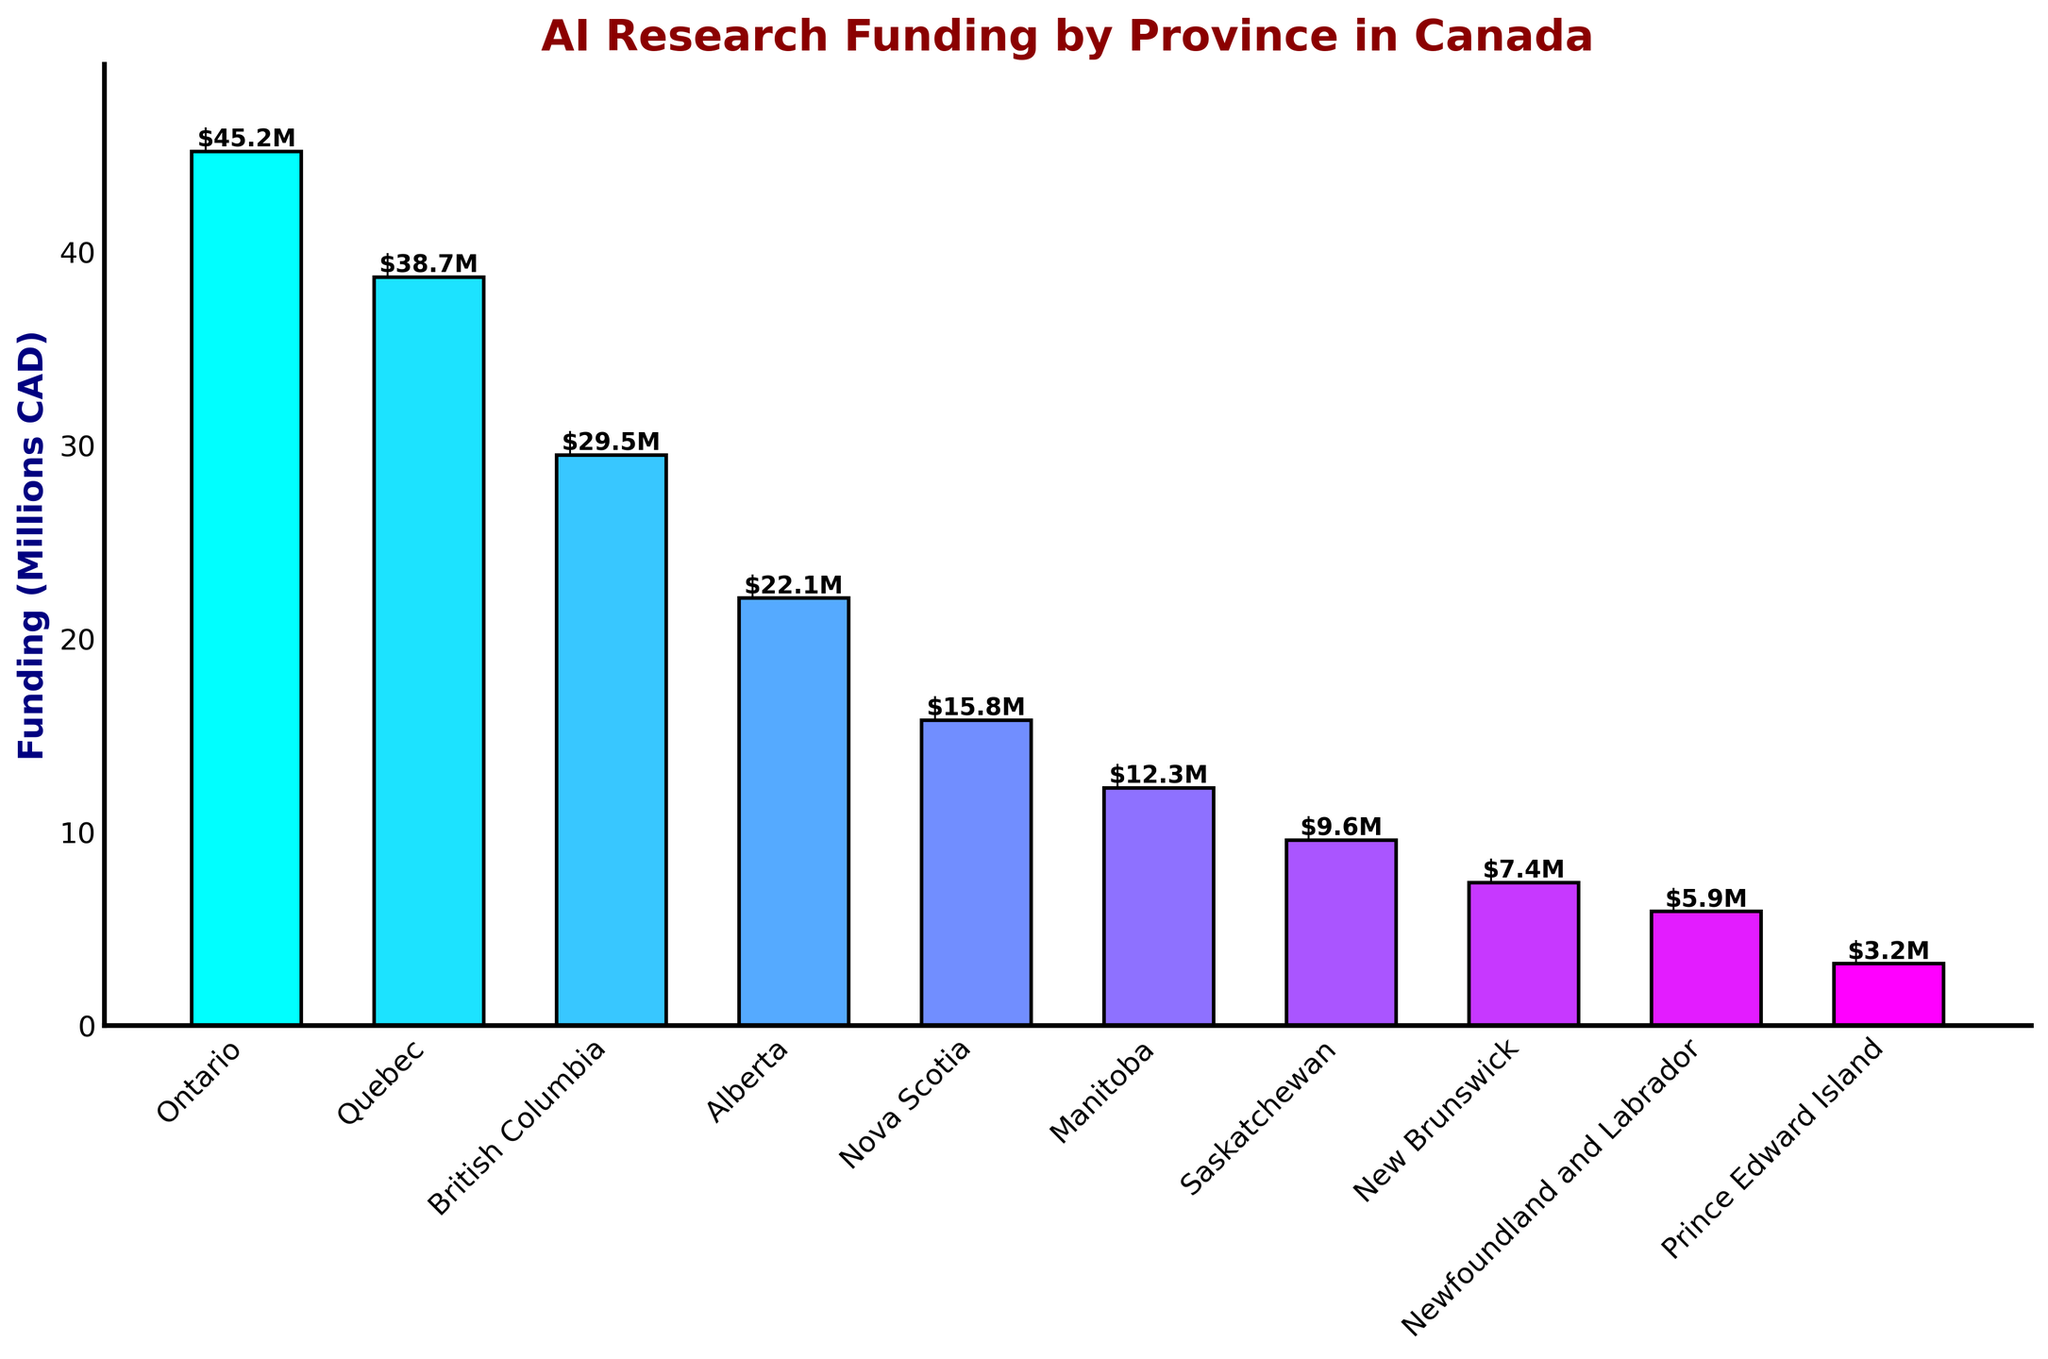Which province received the highest funding for AI research? From the bar chart, we see that the tallest bar belongs to Ontario, indicating it received the highest funding of $45.2 million CAD.
Answer: Ontario Which province received the least funding for AI research? The shortest bar indicates the province with the least funding, which is Prince Edward Island with $3.2 million CAD.
Answer: Prince Edward Island What is the total funding for Alberta and Manitoba combined? Alberta received $22.1 million and Manitoba received $12.3 million. Adding these amounts together, $22.1M + $12.3M = $34.4M.
Answer: $34.4M How much more funding does Quebec receive than British Columbia? Quebec received $38.7 million, while British Columbia received $29.5 million. Subtracting these amounts, $38.7M - $29.5M = $9.2M.
Answer: $9.2M Which provinces received more than $30 million in funding? The provinces with bars taller than $30 million are Ontario and Quebec.
Answer: Ontario, Quebec What is the average funding for the three provinces with the lowest funding? The lowest-funded provinces are Prince Edward Island ($3.2M), Newfoundland and Labrador ($5.9M), and New Brunswick ($7.4M). Their total funding is $3.2M + $5.9M + $7.4M = $16.5M. The average is $16.5M / 3 = $5.5M.
Answer: $5.5M How many provinces received less funding than Nova Scotia? Provinces with less funding than Nova Scotia ($15.8M) are Manitoba, Saskatchewan, New Brunswick, Newfoundland and Labrador, and Prince Edward Island. There are 5 such provinces.
Answer: 5 What is the difference between the funding of Nova Scotia and Prince Edward Island? Nova Scotia received $15.8M, and Prince Edward Island received $3.2M. The difference is $15.8M - $3.2M = $12.6M.
Answer: $12.6M Which province's bar color is the most visually similar to Quebec's bar color? If we examine the colors closely, British Columbia has a color that is visually similar to Quebec's bar color in terms of gradient and shade.
Answer: British Columbia Order the provinces by funding amount, starting with the highest. From highest to lowest funding: Ontario, Quebec, British Columbia, Alberta, Nova Scotia, Manitoba, Saskatchewan, New Brunswick, Newfoundland and Labrador, Prince Edward Island.
Answer: Ontario, Quebec, British Columbia, Alberta, Nova Scotia, Manitoba, Saskatchewan, New Brunswick, Newfoundland and Labrador, Prince Edward Island 